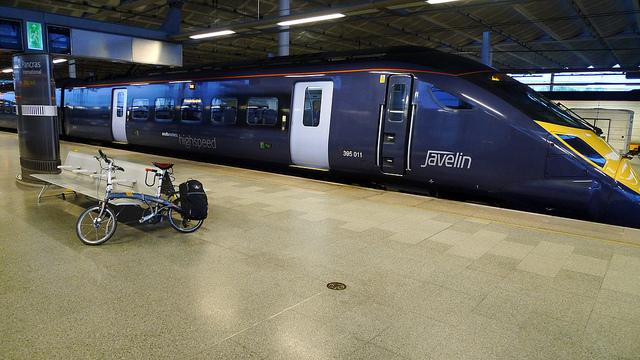How can one tell where the doors are on the train?

Choices:
A) door porter
B) people boarding
C) big sign
D) white color white color 